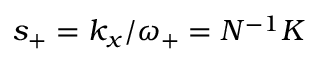Convert formula to latex. <formula><loc_0><loc_0><loc_500><loc_500>s _ { + } = k _ { x } / \omega _ { + } = N ^ { - 1 } K</formula> 